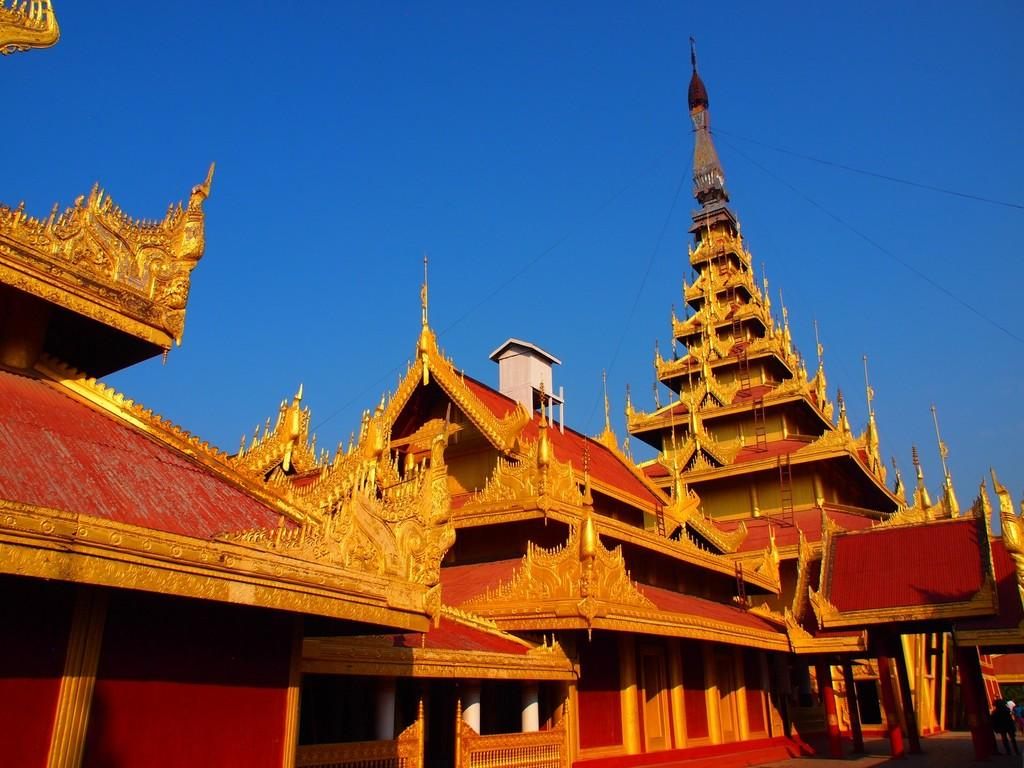What is the main subject of the image? The main subject of the image is the Mandalay palace in Myanmar. What can be seen at the top of the image? The sky is visible at the top of the image. How many jewels are on the hand of the person standing in front of the palace in the image? There is no person or hand with jewels present in the image; it is a picture of the Mandalay palace in Myanmar. What type of ants can be seen crawling on the palace in the image? There are no ants present in the image; it is a picture of the Mandalay palace in Myanmar. 